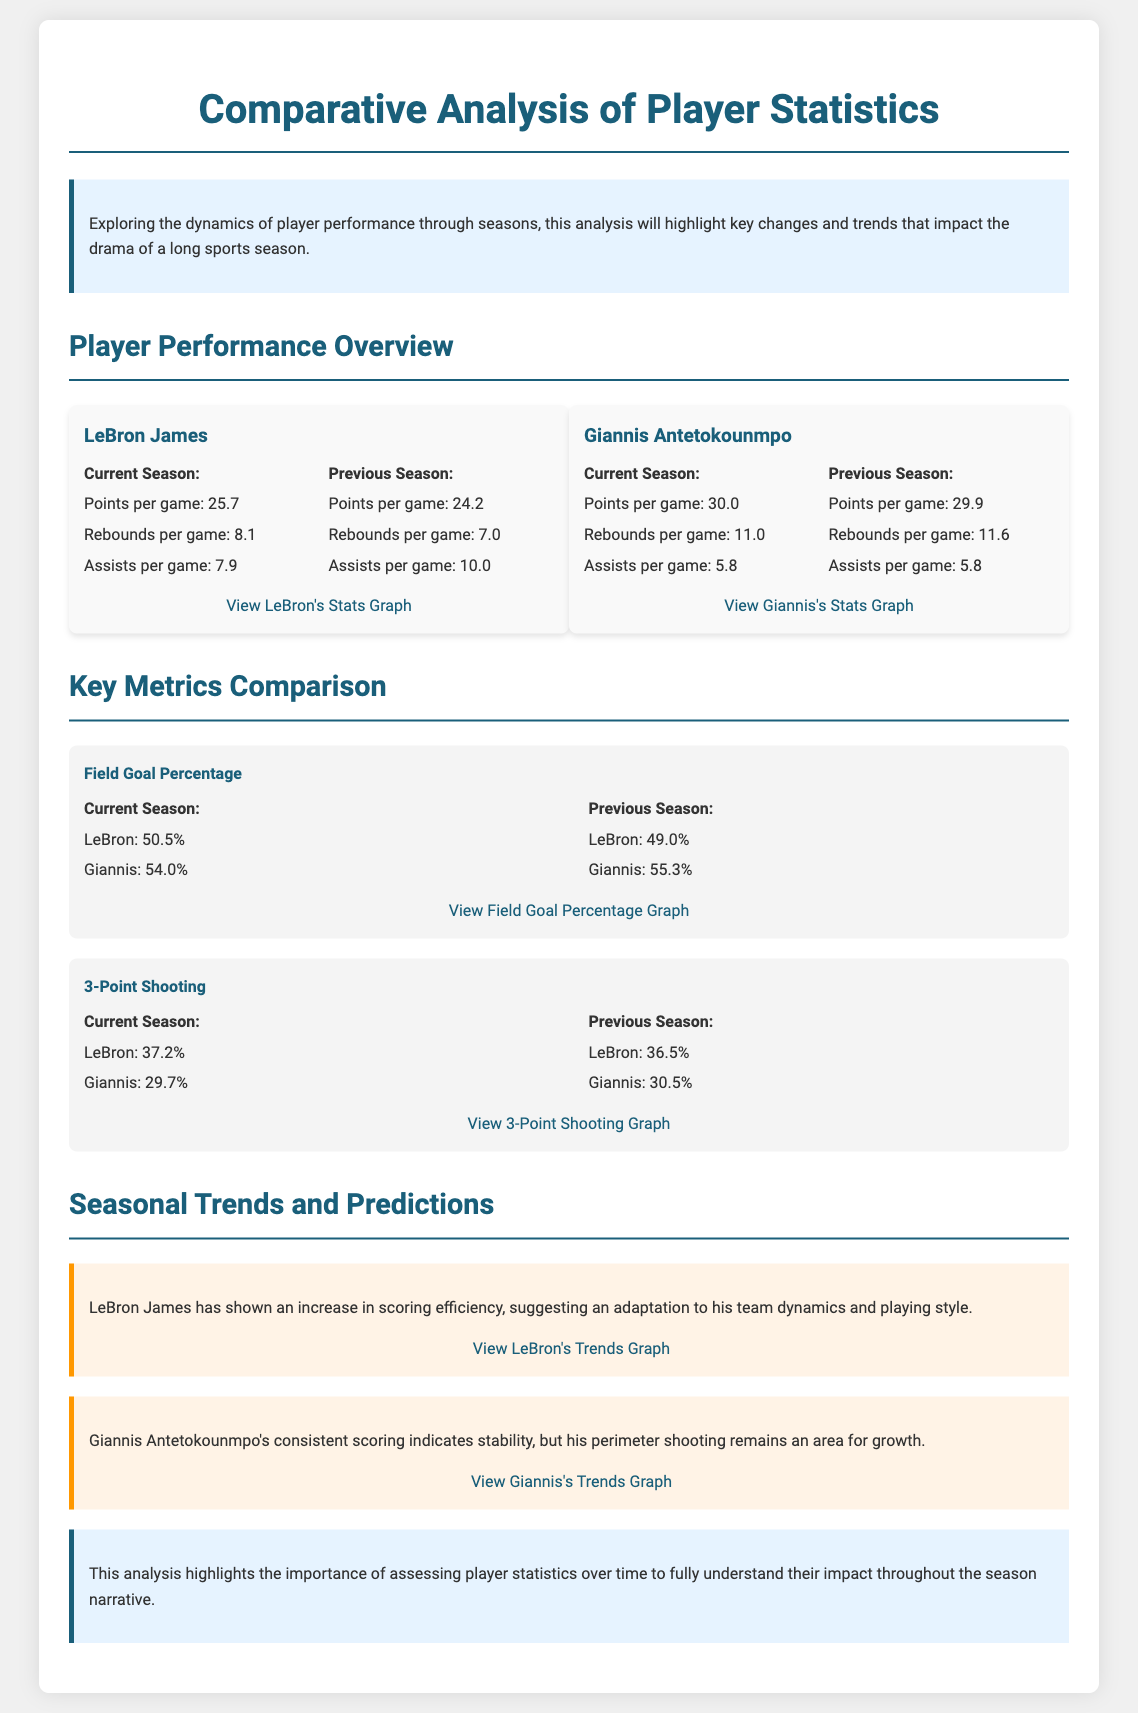What is LeBron James's current points per game? LeBron's current points per game is mentioned in the player statistics section.
Answer: 25.7 What player's rebounds per game showed a decrease from the previous season? When comparing the rebounds per game for LeBron James from this season to last, it decreased from 7.0 to 8.1.
Answer: LeBron James What is Giannis Antetokounmpo's assists per game for the current season? The assists per game for Giannis are specifically listed in his current season statistics.
Answer: 5.8 Which player's field goal percentage increased compared to the previous season? The field goal percentages for both players are compared, showing LeBron's increase from 49.0% to 50.5%.
Answer: LeBron James What was Giannis's 3-point shooting percentage last season? The document specifies Giannis's previous season 3-point shooting percentage.
Answer: 30.5% Which section discusses seasonal trends? The section examining the players' performance trends over the season is labeled for easy identification in the document.
Answer: Seasonal Trends and Predictions How many assists per game did LeBron register in the previous season? The specific number of assists for LeBron James from the previous season is clearly presented.
Answer: 10.0 Which player has a current points per game average of 30.0? The current points per game for Giannis Antetokounmpo is listed in the player statistics.
Answer: Giannis Antetokounmpo 